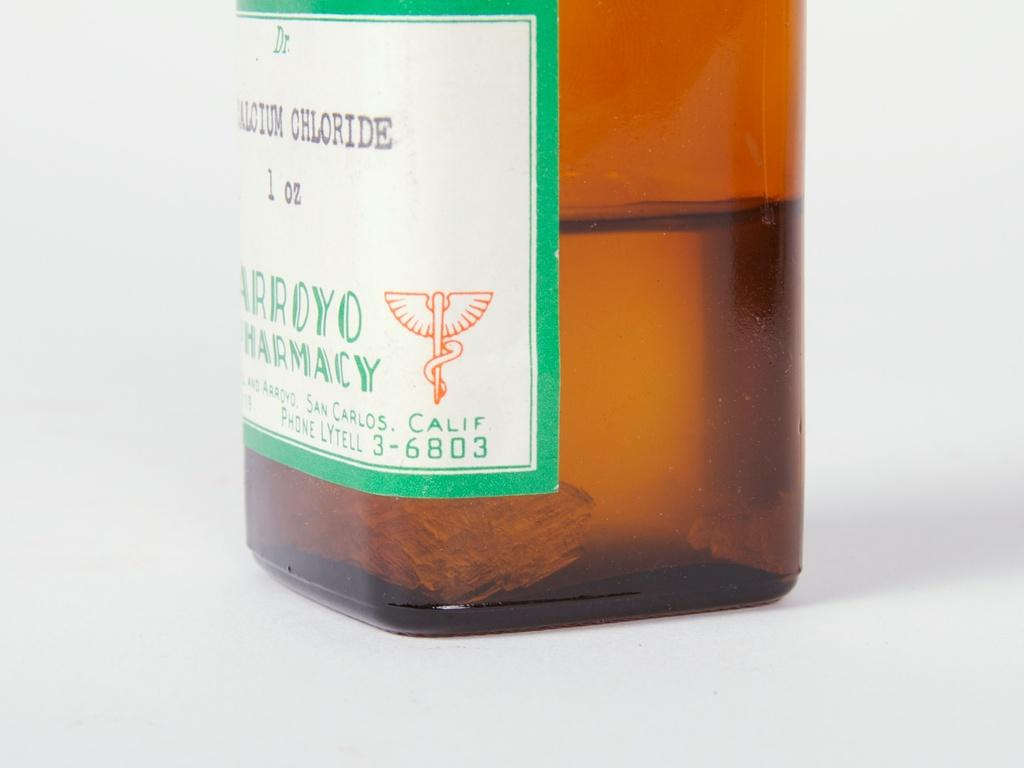<image>
Summarize the visual content of the image. the word chloride is on the front of a liquid bottle 